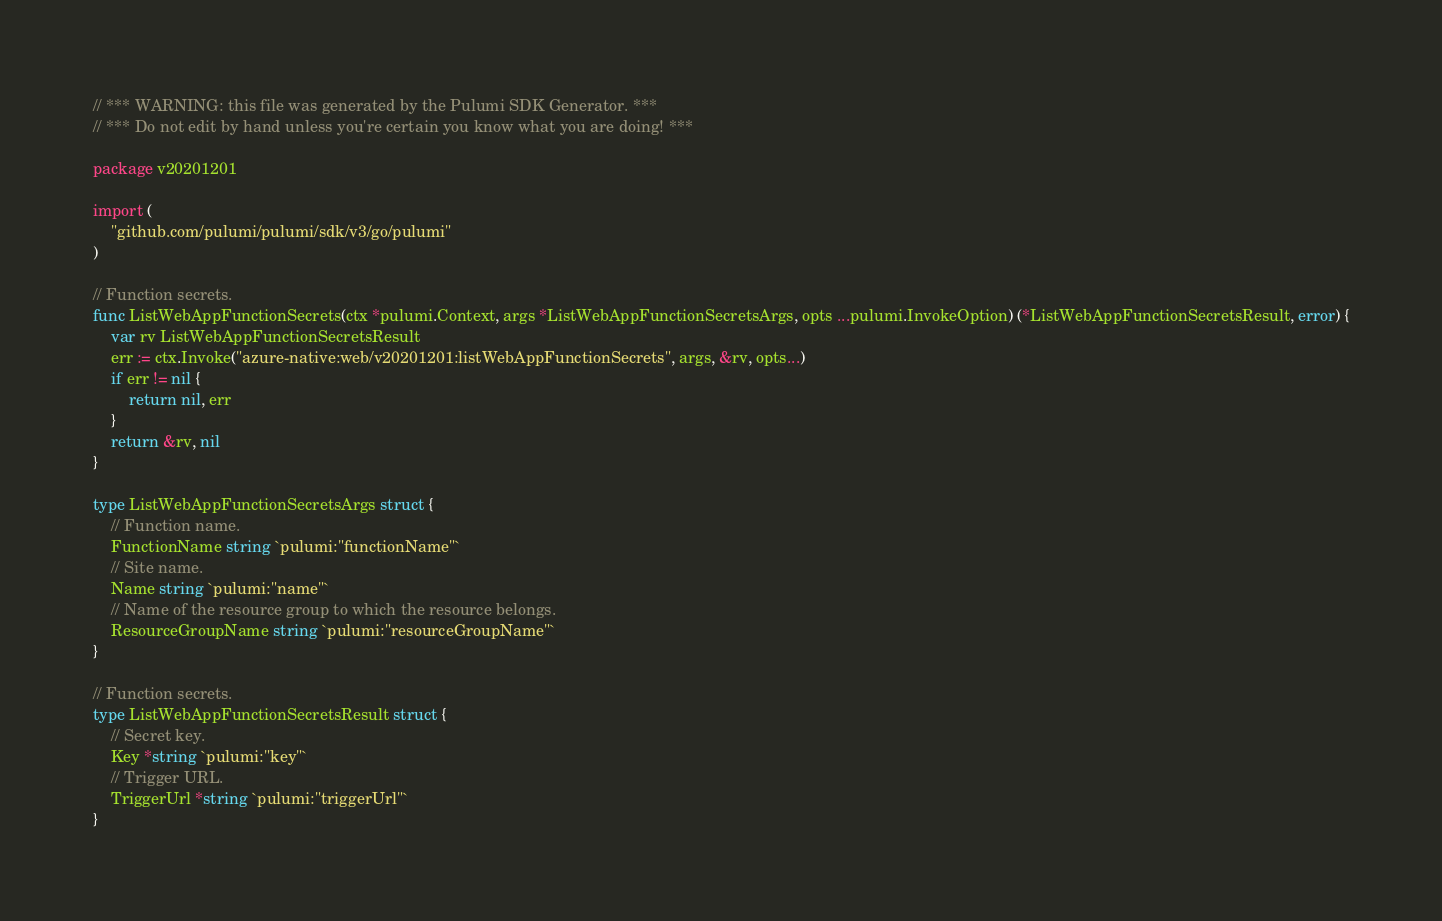Convert code to text. <code><loc_0><loc_0><loc_500><loc_500><_Go_>// *** WARNING: this file was generated by the Pulumi SDK Generator. ***
// *** Do not edit by hand unless you're certain you know what you are doing! ***

package v20201201

import (
	"github.com/pulumi/pulumi/sdk/v3/go/pulumi"
)

// Function secrets.
func ListWebAppFunctionSecrets(ctx *pulumi.Context, args *ListWebAppFunctionSecretsArgs, opts ...pulumi.InvokeOption) (*ListWebAppFunctionSecretsResult, error) {
	var rv ListWebAppFunctionSecretsResult
	err := ctx.Invoke("azure-native:web/v20201201:listWebAppFunctionSecrets", args, &rv, opts...)
	if err != nil {
		return nil, err
	}
	return &rv, nil
}

type ListWebAppFunctionSecretsArgs struct {
	// Function name.
	FunctionName string `pulumi:"functionName"`
	// Site name.
	Name string `pulumi:"name"`
	// Name of the resource group to which the resource belongs.
	ResourceGroupName string `pulumi:"resourceGroupName"`
}

// Function secrets.
type ListWebAppFunctionSecretsResult struct {
	// Secret key.
	Key *string `pulumi:"key"`
	// Trigger URL.
	TriggerUrl *string `pulumi:"triggerUrl"`
}
</code> 